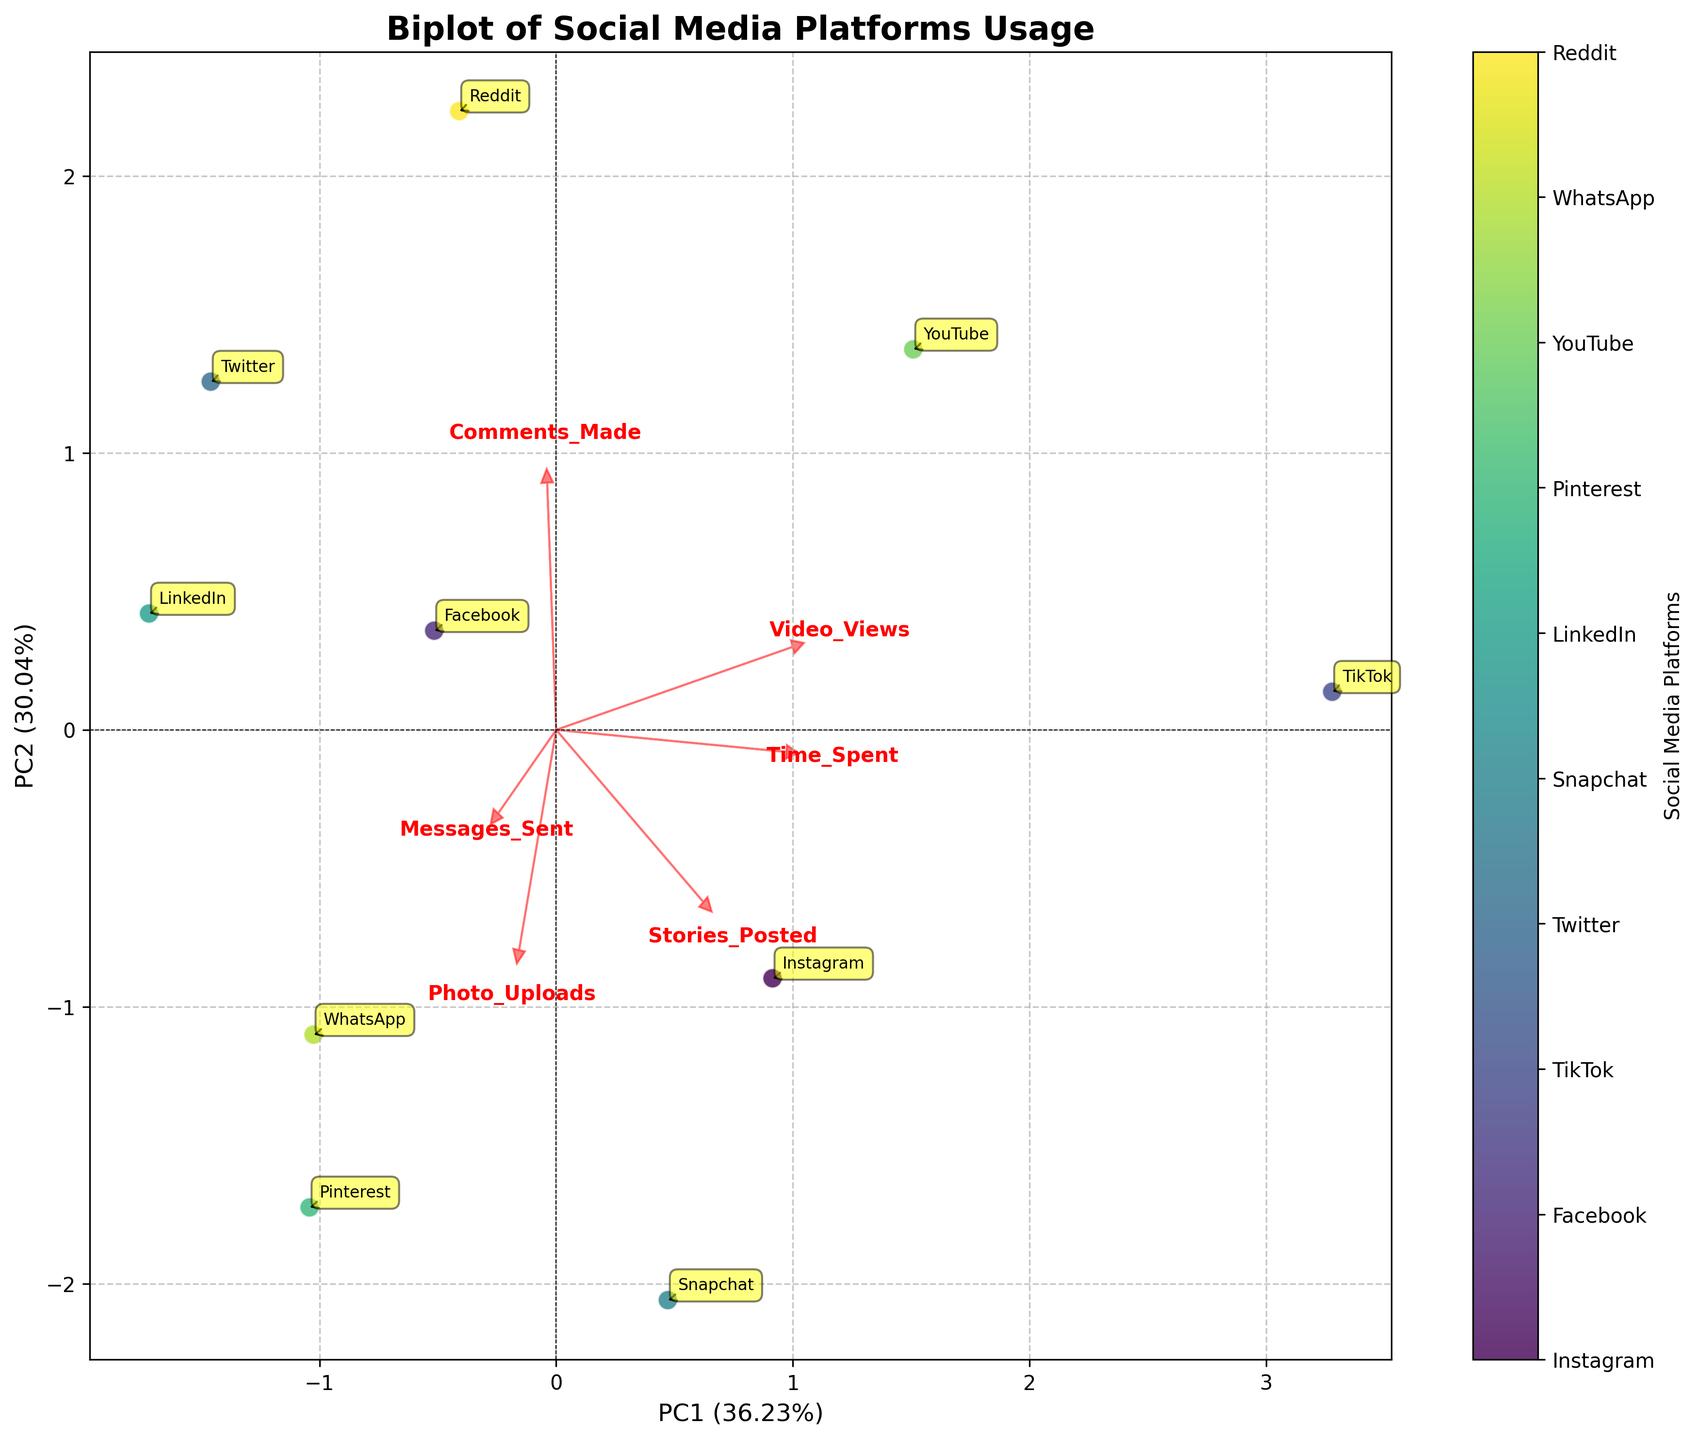Which social media platform is located closest to the center of the plot? To determine which point is closest to the center, we observe where the points are relative to the origin (0,0). LinkedIn appears closest to the center.
Answer: LinkedIn Which direction is "Video_Views" pointing? Look at the red arrows representing each feature. The arrow for "Video_Views" points towards the right and slightly upwards, indicating its positive loadings on both PC1 and PC2.
Answer: Right and slightly upwards How many features have arrows pointing to the bottom-right quadrant? Identify the arrows pointing towards the bottom-right quadrant of the plot. It appears that "Video_Views" and "Messages_Sent" have arrows in this direction.
Answer: 2 Which platform has the highest PC1 score and what does this indicate? By looking at the scatter plot, the platform farthest to the right has the highest PC1 score. TikTok is the farthest to the right, which indicates it has the highest component on PC1, likely correlating with higher engagement as represented by features like "Time_Spent" and "Video_Views."
Answer: TikTok Which features are highly correlated according to the plot? Look for arrows that are closely aligned and point in the same direction, indicating high correlation. For instance, "Time_Spent" and "Video_Views" arrows are pointing almost in the same direction, suggesting high correlation.
Answer: Time_Spent and Video_Views Is "Photo_Uploads" more associated with platforms to the left or right side of PC1? Observe the direction of the "Photo_Uploads" arrow. It points towards the left side of the graph, indicating it is more associated with platforms on the left side of PC1 like Pinterest and Snapchat.
Answer: Left Which feature seems least associated with "Stories_Posted"? Check the proximity and alignment of arrows to determine the association between features. The "Comments_Made" arrow is pointing in a significantly different direction compared to the "Stories_Posted" arrow, indicating a weaker association.
Answer: Comments_Made What percentage of variation is explained by PC1 and PC2 combined? Check the axis labels to see the explained variance for each principal component. PC1 explains around 63% and PC2 explains around 22%, so combined they explain about 85%.
Answer: 85% 